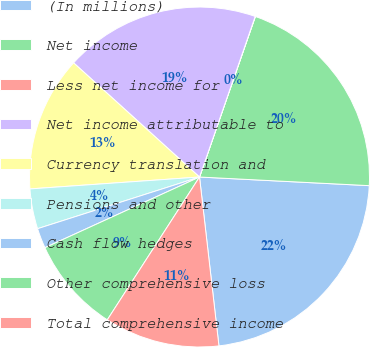Convert chart. <chart><loc_0><loc_0><loc_500><loc_500><pie_chart><fcel>(In millions)<fcel>Net income<fcel>Less net income for<fcel>Net income attributable to<fcel>Currency translation and<fcel>Pensions and other<fcel>Cash flow hedges<fcel>Other comprehensive loss<fcel>Total comprehensive income<nl><fcel>22.37%<fcel>20.48%<fcel>0.02%<fcel>18.59%<fcel>12.84%<fcel>3.8%<fcel>1.91%<fcel>9.05%<fcel>10.95%<nl></chart> 